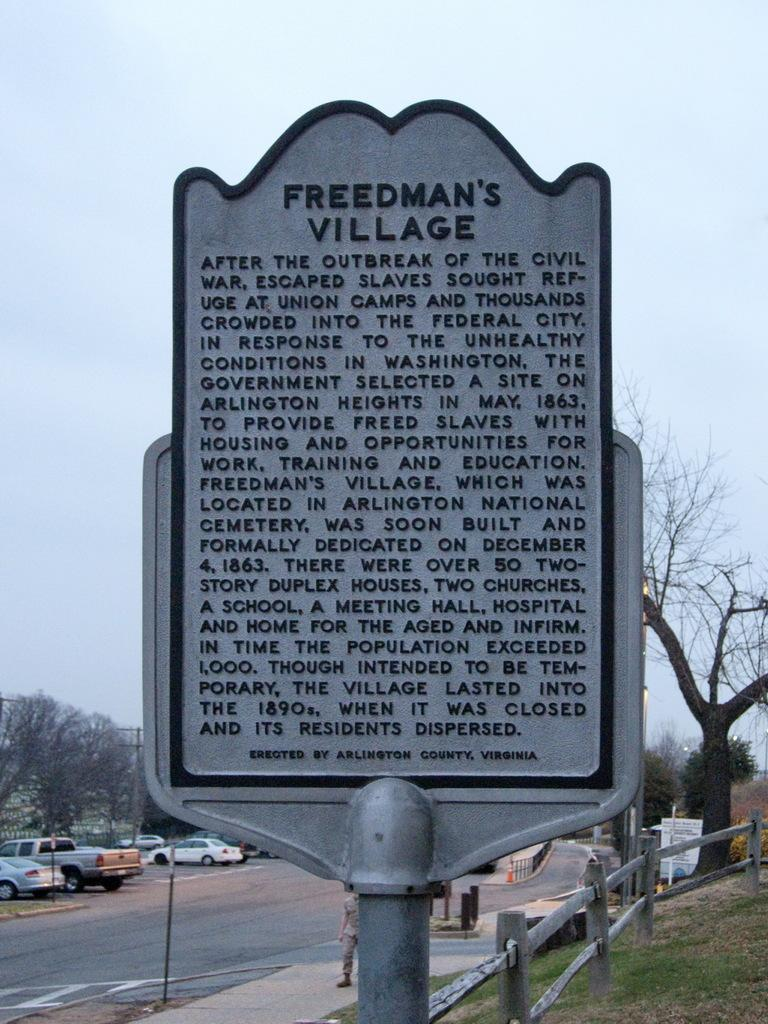What can be seen on the road in the image? There are cars parked on the road in the image. What is present in the background of the image? There is a hoarding and trees in the image. What are the people in the image doing? There are people standing on the footpath in the image. How would you describe the weather in the image? The sky is clear in the image, suggesting good weather. Can you hear the bells ringing in harmony in the image? There are no bells or any indication of sound in the image, so it is not possible to hear anything. Is there a park visible in the image? There is no park present in the image; it features cars, a hoarding, trees, and people standing on the footpath. 